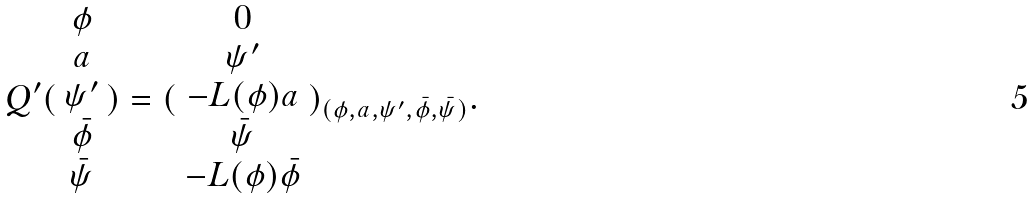Convert formula to latex. <formula><loc_0><loc_0><loc_500><loc_500>Q ^ { \prime } ( \begin{array} { c } \phi \\ a \\ \psi ^ { \prime } \\ \bar { \phi } \\ \bar { \psi } \end{array} ) = ( \begin{array} { c } 0 \\ \psi ^ { \prime } \\ - L ( \phi ) a \\ \bar { \psi } \\ - L ( \phi ) \bar { \phi } \end{array} ) _ { ( \phi , a , \psi ^ { \prime } , \bar { \phi } , \bar { \psi } ) } .</formula> 